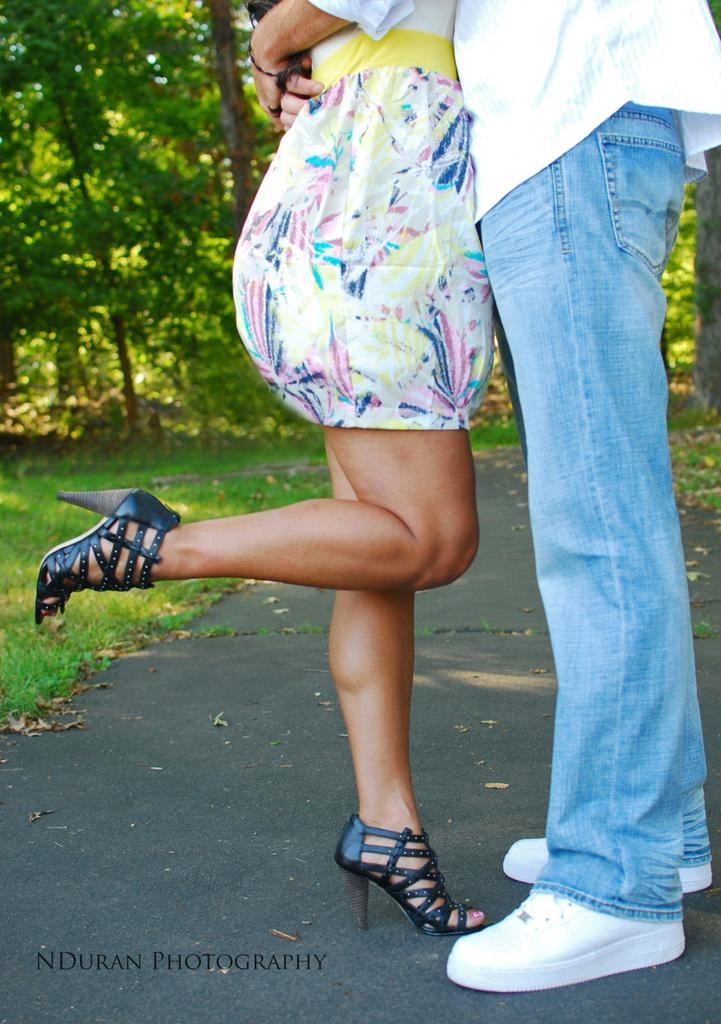How many people are in the image? There are two persons standing in the front of the image. What is on the left side of the image? There is grass on the left side of the image. What can be seen in the background of the image? There are trees visible in the background of the image. What type of popcorn is being used as a hair accessory by one of the persons in the image? There is no popcorn or hair accessory present in the image. Can you describe the behavior of the trees in the background? The trees in the background are not exhibiting any behavior, as they are inanimate objects. 